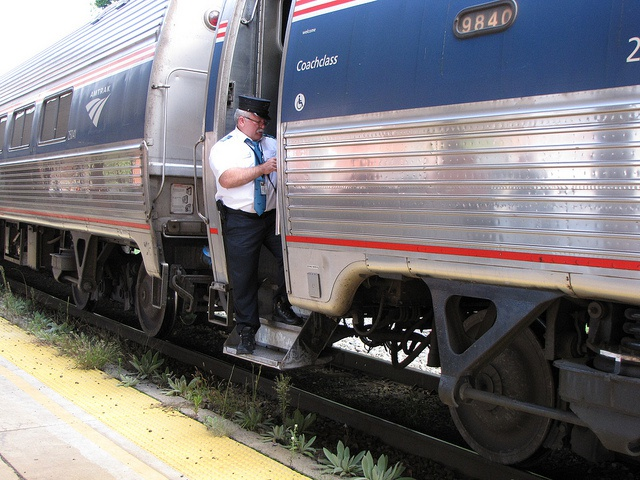Describe the objects in this image and their specific colors. I can see train in white, black, darkgray, lightgray, and gray tones, people in white, black, darkgray, and lightpink tones, and tie in white, blue, navy, and gray tones in this image. 